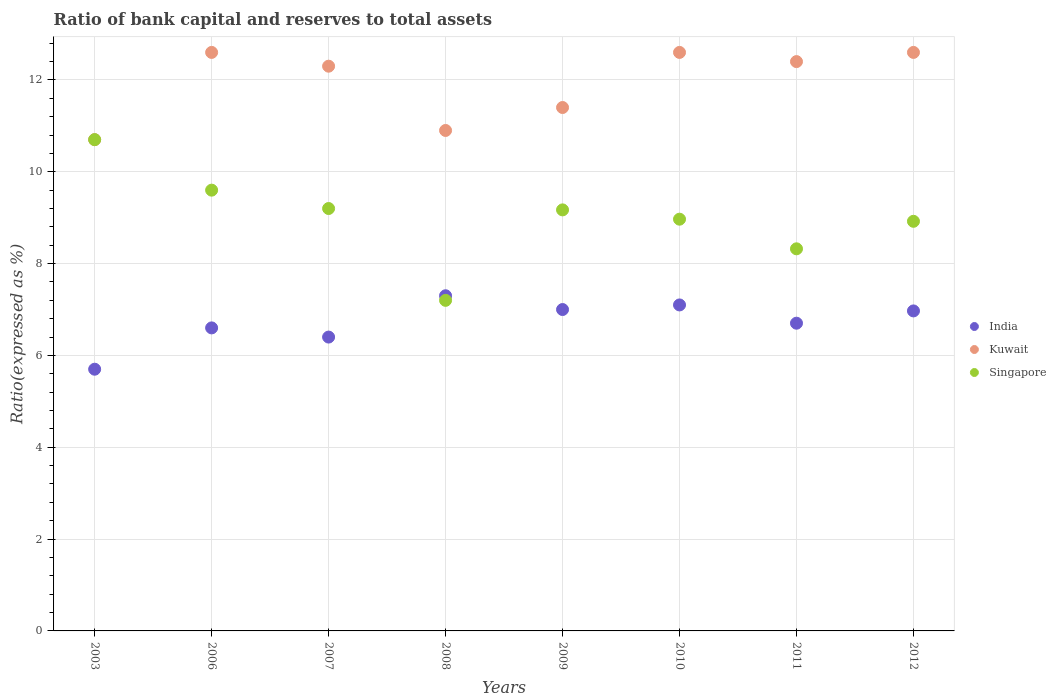Is the number of dotlines equal to the number of legend labels?
Offer a very short reply. Yes. Across all years, what is the minimum ratio of bank capital and reserves to total assets in Kuwait?
Provide a succinct answer. 10.7. What is the total ratio of bank capital and reserves to total assets in India in the graph?
Offer a very short reply. 53.77. What is the difference between the ratio of bank capital and reserves to total assets in India in 2009 and that in 2012?
Keep it short and to the point. 0.03. What is the difference between the ratio of bank capital and reserves to total assets in Singapore in 2003 and the ratio of bank capital and reserves to total assets in India in 2012?
Ensure brevity in your answer.  3.73. What is the average ratio of bank capital and reserves to total assets in Kuwait per year?
Give a very brief answer. 11.94. In the year 2009, what is the difference between the ratio of bank capital and reserves to total assets in India and ratio of bank capital and reserves to total assets in Singapore?
Your answer should be compact. -2.17. In how many years, is the ratio of bank capital and reserves to total assets in India greater than 8.8 %?
Offer a terse response. 0. What is the ratio of the ratio of bank capital and reserves to total assets in India in 2009 to that in 2010?
Give a very brief answer. 0.99. Is the difference between the ratio of bank capital and reserves to total assets in India in 2011 and 2012 greater than the difference between the ratio of bank capital and reserves to total assets in Singapore in 2011 and 2012?
Offer a terse response. Yes. What is the difference between the highest and the lowest ratio of bank capital and reserves to total assets in Singapore?
Provide a succinct answer. 3.5. Is the sum of the ratio of bank capital and reserves to total assets in India in 2006 and 2010 greater than the maximum ratio of bank capital and reserves to total assets in Kuwait across all years?
Keep it short and to the point. Yes. Is it the case that in every year, the sum of the ratio of bank capital and reserves to total assets in India and ratio of bank capital and reserves to total assets in Kuwait  is greater than the ratio of bank capital and reserves to total assets in Singapore?
Your response must be concise. Yes. Does the ratio of bank capital and reserves to total assets in Singapore monotonically increase over the years?
Your answer should be compact. No. Is the ratio of bank capital and reserves to total assets in Singapore strictly greater than the ratio of bank capital and reserves to total assets in India over the years?
Your response must be concise. No. How many years are there in the graph?
Give a very brief answer. 8. What is the difference between two consecutive major ticks on the Y-axis?
Your answer should be very brief. 2. Does the graph contain any zero values?
Give a very brief answer. No. Does the graph contain grids?
Your answer should be compact. Yes. What is the title of the graph?
Offer a terse response. Ratio of bank capital and reserves to total assets. What is the label or title of the Y-axis?
Provide a short and direct response. Ratio(expressed as %). What is the Ratio(expressed as %) of India in 2003?
Your answer should be very brief. 5.7. What is the Ratio(expressed as %) in Kuwait in 2003?
Provide a succinct answer. 10.7. What is the Ratio(expressed as %) in Singapore in 2003?
Provide a succinct answer. 10.7. What is the Ratio(expressed as %) of India in 2006?
Offer a terse response. 6.6. What is the Ratio(expressed as %) of Singapore in 2006?
Offer a terse response. 9.6. What is the Ratio(expressed as %) of India in 2007?
Your response must be concise. 6.4. What is the Ratio(expressed as %) in Kuwait in 2007?
Make the answer very short. 12.3. What is the Ratio(expressed as %) in Singapore in 2007?
Keep it short and to the point. 9.2. What is the Ratio(expressed as %) in Singapore in 2008?
Provide a short and direct response. 7.2. What is the Ratio(expressed as %) of Kuwait in 2009?
Ensure brevity in your answer.  11.4. What is the Ratio(expressed as %) in Singapore in 2009?
Provide a succinct answer. 9.17. What is the Ratio(expressed as %) in India in 2010?
Your answer should be compact. 7.1. What is the Ratio(expressed as %) in Kuwait in 2010?
Offer a terse response. 12.6. What is the Ratio(expressed as %) in Singapore in 2010?
Provide a succinct answer. 8.97. What is the Ratio(expressed as %) in India in 2011?
Provide a succinct answer. 6.7. What is the Ratio(expressed as %) in Kuwait in 2011?
Make the answer very short. 12.4. What is the Ratio(expressed as %) of Singapore in 2011?
Give a very brief answer. 8.32. What is the Ratio(expressed as %) in India in 2012?
Provide a short and direct response. 6.97. What is the Ratio(expressed as %) in Kuwait in 2012?
Provide a succinct answer. 12.6. What is the Ratio(expressed as %) in Singapore in 2012?
Ensure brevity in your answer.  8.92. Across all years, what is the maximum Ratio(expressed as %) of Singapore?
Your response must be concise. 10.7. Across all years, what is the minimum Ratio(expressed as %) in Singapore?
Keep it short and to the point. 7.2. What is the total Ratio(expressed as %) in India in the graph?
Provide a short and direct response. 53.77. What is the total Ratio(expressed as %) of Kuwait in the graph?
Make the answer very short. 95.5. What is the total Ratio(expressed as %) of Singapore in the graph?
Your answer should be compact. 72.08. What is the difference between the Ratio(expressed as %) of Kuwait in 2003 and that in 2006?
Your answer should be compact. -1.9. What is the difference between the Ratio(expressed as %) of India in 2003 and that in 2008?
Your answer should be very brief. -1.6. What is the difference between the Ratio(expressed as %) of Kuwait in 2003 and that in 2008?
Offer a very short reply. -0.2. What is the difference between the Ratio(expressed as %) in India in 2003 and that in 2009?
Keep it short and to the point. -1.3. What is the difference between the Ratio(expressed as %) in Kuwait in 2003 and that in 2009?
Provide a succinct answer. -0.7. What is the difference between the Ratio(expressed as %) in Singapore in 2003 and that in 2009?
Your answer should be compact. 1.53. What is the difference between the Ratio(expressed as %) of Kuwait in 2003 and that in 2010?
Provide a succinct answer. -1.9. What is the difference between the Ratio(expressed as %) of Singapore in 2003 and that in 2010?
Provide a succinct answer. 1.73. What is the difference between the Ratio(expressed as %) of India in 2003 and that in 2011?
Your response must be concise. -1. What is the difference between the Ratio(expressed as %) in Singapore in 2003 and that in 2011?
Your response must be concise. 2.38. What is the difference between the Ratio(expressed as %) of India in 2003 and that in 2012?
Offer a very short reply. -1.27. What is the difference between the Ratio(expressed as %) of Singapore in 2003 and that in 2012?
Your answer should be very brief. 1.78. What is the difference between the Ratio(expressed as %) of India in 2006 and that in 2007?
Your answer should be very brief. 0.2. What is the difference between the Ratio(expressed as %) of Singapore in 2006 and that in 2007?
Make the answer very short. 0.4. What is the difference between the Ratio(expressed as %) of India in 2006 and that in 2008?
Your response must be concise. -0.7. What is the difference between the Ratio(expressed as %) of Kuwait in 2006 and that in 2008?
Offer a terse response. 1.7. What is the difference between the Ratio(expressed as %) of Kuwait in 2006 and that in 2009?
Your answer should be compact. 1.2. What is the difference between the Ratio(expressed as %) of Singapore in 2006 and that in 2009?
Provide a short and direct response. 0.43. What is the difference between the Ratio(expressed as %) of India in 2006 and that in 2010?
Provide a short and direct response. -0.5. What is the difference between the Ratio(expressed as %) in Kuwait in 2006 and that in 2010?
Offer a very short reply. 0. What is the difference between the Ratio(expressed as %) of Singapore in 2006 and that in 2010?
Keep it short and to the point. 0.63. What is the difference between the Ratio(expressed as %) in India in 2006 and that in 2011?
Ensure brevity in your answer.  -0.1. What is the difference between the Ratio(expressed as %) of Kuwait in 2006 and that in 2011?
Your response must be concise. 0.2. What is the difference between the Ratio(expressed as %) in Singapore in 2006 and that in 2011?
Your answer should be very brief. 1.28. What is the difference between the Ratio(expressed as %) of India in 2006 and that in 2012?
Make the answer very short. -0.37. What is the difference between the Ratio(expressed as %) of Kuwait in 2006 and that in 2012?
Provide a short and direct response. 0. What is the difference between the Ratio(expressed as %) in Singapore in 2006 and that in 2012?
Ensure brevity in your answer.  0.68. What is the difference between the Ratio(expressed as %) of Kuwait in 2007 and that in 2008?
Offer a terse response. 1.4. What is the difference between the Ratio(expressed as %) in Singapore in 2007 and that in 2008?
Keep it short and to the point. 2. What is the difference between the Ratio(expressed as %) of Singapore in 2007 and that in 2009?
Give a very brief answer. 0.03. What is the difference between the Ratio(expressed as %) in Kuwait in 2007 and that in 2010?
Give a very brief answer. -0.3. What is the difference between the Ratio(expressed as %) in Singapore in 2007 and that in 2010?
Give a very brief answer. 0.23. What is the difference between the Ratio(expressed as %) of India in 2007 and that in 2011?
Provide a succinct answer. -0.3. What is the difference between the Ratio(expressed as %) of Kuwait in 2007 and that in 2011?
Provide a succinct answer. -0.1. What is the difference between the Ratio(expressed as %) in Singapore in 2007 and that in 2011?
Your answer should be very brief. 0.88. What is the difference between the Ratio(expressed as %) of India in 2007 and that in 2012?
Keep it short and to the point. -0.57. What is the difference between the Ratio(expressed as %) of Singapore in 2007 and that in 2012?
Provide a short and direct response. 0.28. What is the difference between the Ratio(expressed as %) in Singapore in 2008 and that in 2009?
Offer a very short reply. -1.97. What is the difference between the Ratio(expressed as %) of India in 2008 and that in 2010?
Provide a succinct answer. 0.2. What is the difference between the Ratio(expressed as %) in Kuwait in 2008 and that in 2010?
Your response must be concise. -1.7. What is the difference between the Ratio(expressed as %) of Singapore in 2008 and that in 2010?
Your answer should be very brief. -1.77. What is the difference between the Ratio(expressed as %) of India in 2008 and that in 2011?
Offer a very short reply. 0.6. What is the difference between the Ratio(expressed as %) of Kuwait in 2008 and that in 2011?
Keep it short and to the point. -1.5. What is the difference between the Ratio(expressed as %) in Singapore in 2008 and that in 2011?
Give a very brief answer. -1.12. What is the difference between the Ratio(expressed as %) of India in 2008 and that in 2012?
Provide a succinct answer. 0.33. What is the difference between the Ratio(expressed as %) of Singapore in 2008 and that in 2012?
Offer a very short reply. -1.72. What is the difference between the Ratio(expressed as %) of India in 2009 and that in 2010?
Provide a succinct answer. -0.1. What is the difference between the Ratio(expressed as %) of Kuwait in 2009 and that in 2010?
Provide a short and direct response. -1.2. What is the difference between the Ratio(expressed as %) of Singapore in 2009 and that in 2010?
Offer a terse response. 0.2. What is the difference between the Ratio(expressed as %) in India in 2009 and that in 2011?
Provide a succinct answer. 0.3. What is the difference between the Ratio(expressed as %) in Kuwait in 2009 and that in 2011?
Your response must be concise. -1. What is the difference between the Ratio(expressed as %) in Singapore in 2009 and that in 2011?
Your response must be concise. 0.85. What is the difference between the Ratio(expressed as %) in India in 2009 and that in 2012?
Your answer should be compact. 0.03. What is the difference between the Ratio(expressed as %) in Kuwait in 2009 and that in 2012?
Provide a short and direct response. -1.2. What is the difference between the Ratio(expressed as %) of Singapore in 2009 and that in 2012?
Offer a terse response. 0.25. What is the difference between the Ratio(expressed as %) in India in 2010 and that in 2011?
Offer a terse response. 0.4. What is the difference between the Ratio(expressed as %) of Singapore in 2010 and that in 2011?
Give a very brief answer. 0.65. What is the difference between the Ratio(expressed as %) of India in 2010 and that in 2012?
Ensure brevity in your answer.  0.13. What is the difference between the Ratio(expressed as %) of Singapore in 2010 and that in 2012?
Your answer should be very brief. 0.05. What is the difference between the Ratio(expressed as %) in India in 2011 and that in 2012?
Give a very brief answer. -0.27. What is the difference between the Ratio(expressed as %) in Kuwait in 2011 and that in 2012?
Your answer should be very brief. -0.2. What is the difference between the Ratio(expressed as %) of Singapore in 2011 and that in 2012?
Your response must be concise. -0.6. What is the difference between the Ratio(expressed as %) of India in 2003 and the Ratio(expressed as %) of Singapore in 2006?
Your answer should be very brief. -3.9. What is the difference between the Ratio(expressed as %) in Kuwait in 2003 and the Ratio(expressed as %) in Singapore in 2007?
Give a very brief answer. 1.5. What is the difference between the Ratio(expressed as %) in India in 2003 and the Ratio(expressed as %) in Kuwait in 2008?
Offer a terse response. -5.2. What is the difference between the Ratio(expressed as %) in India in 2003 and the Ratio(expressed as %) in Singapore in 2008?
Offer a terse response. -1.5. What is the difference between the Ratio(expressed as %) in India in 2003 and the Ratio(expressed as %) in Singapore in 2009?
Make the answer very short. -3.47. What is the difference between the Ratio(expressed as %) of Kuwait in 2003 and the Ratio(expressed as %) of Singapore in 2009?
Your answer should be very brief. 1.53. What is the difference between the Ratio(expressed as %) in India in 2003 and the Ratio(expressed as %) in Kuwait in 2010?
Offer a very short reply. -6.9. What is the difference between the Ratio(expressed as %) of India in 2003 and the Ratio(expressed as %) of Singapore in 2010?
Provide a succinct answer. -3.27. What is the difference between the Ratio(expressed as %) of Kuwait in 2003 and the Ratio(expressed as %) of Singapore in 2010?
Ensure brevity in your answer.  1.73. What is the difference between the Ratio(expressed as %) in India in 2003 and the Ratio(expressed as %) in Kuwait in 2011?
Offer a terse response. -6.7. What is the difference between the Ratio(expressed as %) of India in 2003 and the Ratio(expressed as %) of Singapore in 2011?
Your answer should be very brief. -2.62. What is the difference between the Ratio(expressed as %) of Kuwait in 2003 and the Ratio(expressed as %) of Singapore in 2011?
Your response must be concise. 2.38. What is the difference between the Ratio(expressed as %) of India in 2003 and the Ratio(expressed as %) of Singapore in 2012?
Offer a very short reply. -3.22. What is the difference between the Ratio(expressed as %) of Kuwait in 2003 and the Ratio(expressed as %) of Singapore in 2012?
Ensure brevity in your answer.  1.78. What is the difference between the Ratio(expressed as %) in India in 2006 and the Ratio(expressed as %) in Singapore in 2007?
Your answer should be very brief. -2.6. What is the difference between the Ratio(expressed as %) of Kuwait in 2006 and the Ratio(expressed as %) of Singapore in 2007?
Make the answer very short. 3.4. What is the difference between the Ratio(expressed as %) in India in 2006 and the Ratio(expressed as %) in Singapore in 2009?
Provide a short and direct response. -2.57. What is the difference between the Ratio(expressed as %) in Kuwait in 2006 and the Ratio(expressed as %) in Singapore in 2009?
Ensure brevity in your answer.  3.43. What is the difference between the Ratio(expressed as %) in India in 2006 and the Ratio(expressed as %) in Kuwait in 2010?
Keep it short and to the point. -6. What is the difference between the Ratio(expressed as %) in India in 2006 and the Ratio(expressed as %) in Singapore in 2010?
Your response must be concise. -2.37. What is the difference between the Ratio(expressed as %) of Kuwait in 2006 and the Ratio(expressed as %) of Singapore in 2010?
Ensure brevity in your answer.  3.63. What is the difference between the Ratio(expressed as %) of India in 2006 and the Ratio(expressed as %) of Singapore in 2011?
Provide a short and direct response. -1.72. What is the difference between the Ratio(expressed as %) of Kuwait in 2006 and the Ratio(expressed as %) of Singapore in 2011?
Offer a very short reply. 4.28. What is the difference between the Ratio(expressed as %) of India in 2006 and the Ratio(expressed as %) of Kuwait in 2012?
Ensure brevity in your answer.  -6. What is the difference between the Ratio(expressed as %) in India in 2006 and the Ratio(expressed as %) in Singapore in 2012?
Keep it short and to the point. -2.32. What is the difference between the Ratio(expressed as %) in Kuwait in 2006 and the Ratio(expressed as %) in Singapore in 2012?
Make the answer very short. 3.68. What is the difference between the Ratio(expressed as %) of India in 2007 and the Ratio(expressed as %) of Kuwait in 2008?
Your answer should be compact. -4.5. What is the difference between the Ratio(expressed as %) in India in 2007 and the Ratio(expressed as %) in Singapore in 2008?
Provide a succinct answer. -0.8. What is the difference between the Ratio(expressed as %) in India in 2007 and the Ratio(expressed as %) in Singapore in 2009?
Give a very brief answer. -2.77. What is the difference between the Ratio(expressed as %) of Kuwait in 2007 and the Ratio(expressed as %) of Singapore in 2009?
Offer a very short reply. 3.13. What is the difference between the Ratio(expressed as %) of India in 2007 and the Ratio(expressed as %) of Kuwait in 2010?
Provide a short and direct response. -6.2. What is the difference between the Ratio(expressed as %) in India in 2007 and the Ratio(expressed as %) in Singapore in 2010?
Offer a very short reply. -2.57. What is the difference between the Ratio(expressed as %) of Kuwait in 2007 and the Ratio(expressed as %) of Singapore in 2010?
Your answer should be very brief. 3.33. What is the difference between the Ratio(expressed as %) in India in 2007 and the Ratio(expressed as %) in Singapore in 2011?
Your answer should be compact. -1.92. What is the difference between the Ratio(expressed as %) of Kuwait in 2007 and the Ratio(expressed as %) of Singapore in 2011?
Provide a short and direct response. 3.98. What is the difference between the Ratio(expressed as %) in India in 2007 and the Ratio(expressed as %) in Singapore in 2012?
Make the answer very short. -2.52. What is the difference between the Ratio(expressed as %) of Kuwait in 2007 and the Ratio(expressed as %) of Singapore in 2012?
Your answer should be compact. 3.38. What is the difference between the Ratio(expressed as %) in India in 2008 and the Ratio(expressed as %) in Kuwait in 2009?
Ensure brevity in your answer.  -4.1. What is the difference between the Ratio(expressed as %) of India in 2008 and the Ratio(expressed as %) of Singapore in 2009?
Provide a succinct answer. -1.87. What is the difference between the Ratio(expressed as %) in Kuwait in 2008 and the Ratio(expressed as %) in Singapore in 2009?
Your response must be concise. 1.73. What is the difference between the Ratio(expressed as %) of India in 2008 and the Ratio(expressed as %) of Kuwait in 2010?
Provide a short and direct response. -5.3. What is the difference between the Ratio(expressed as %) of India in 2008 and the Ratio(expressed as %) of Singapore in 2010?
Give a very brief answer. -1.67. What is the difference between the Ratio(expressed as %) in Kuwait in 2008 and the Ratio(expressed as %) in Singapore in 2010?
Keep it short and to the point. 1.93. What is the difference between the Ratio(expressed as %) in India in 2008 and the Ratio(expressed as %) in Kuwait in 2011?
Keep it short and to the point. -5.1. What is the difference between the Ratio(expressed as %) in India in 2008 and the Ratio(expressed as %) in Singapore in 2011?
Offer a terse response. -1.02. What is the difference between the Ratio(expressed as %) of Kuwait in 2008 and the Ratio(expressed as %) of Singapore in 2011?
Offer a terse response. 2.58. What is the difference between the Ratio(expressed as %) in India in 2008 and the Ratio(expressed as %) in Singapore in 2012?
Your answer should be compact. -1.62. What is the difference between the Ratio(expressed as %) of Kuwait in 2008 and the Ratio(expressed as %) of Singapore in 2012?
Your answer should be compact. 1.98. What is the difference between the Ratio(expressed as %) of India in 2009 and the Ratio(expressed as %) of Kuwait in 2010?
Ensure brevity in your answer.  -5.6. What is the difference between the Ratio(expressed as %) in India in 2009 and the Ratio(expressed as %) in Singapore in 2010?
Your response must be concise. -1.97. What is the difference between the Ratio(expressed as %) in Kuwait in 2009 and the Ratio(expressed as %) in Singapore in 2010?
Keep it short and to the point. 2.43. What is the difference between the Ratio(expressed as %) in India in 2009 and the Ratio(expressed as %) in Kuwait in 2011?
Provide a short and direct response. -5.4. What is the difference between the Ratio(expressed as %) in India in 2009 and the Ratio(expressed as %) in Singapore in 2011?
Your answer should be very brief. -1.32. What is the difference between the Ratio(expressed as %) of Kuwait in 2009 and the Ratio(expressed as %) of Singapore in 2011?
Your response must be concise. 3.08. What is the difference between the Ratio(expressed as %) of India in 2009 and the Ratio(expressed as %) of Kuwait in 2012?
Provide a short and direct response. -5.6. What is the difference between the Ratio(expressed as %) of India in 2009 and the Ratio(expressed as %) of Singapore in 2012?
Your answer should be very brief. -1.92. What is the difference between the Ratio(expressed as %) of Kuwait in 2009 and the Ratio(expressed as %) of Singapore in 2012?
Provide a short and direct response. 2.48. What is the difference between the Ratio(expressed as %) of India in 2010 and the Ratio(expressed as %) of Kuwait in 2011?
Make the answer very short. -5.3. What is the difference between the Ratio(expressed as %) of India in 2010 and the Ratio(expressed as %) of Singapore in 2011?
Make the answer very short. -1.22. What is the difference between the Ratio(expressed as %) of Kuwait in 2010 and the Ratio(expressed as %) of Singapore in 2011?
Your answer should be compact. 4.28. What is the difference between the Ratio(expressed as %) of India in 2010 and the Ratio(expressed as %) of Kuwait in 2012?
Provide a short and direct response. -5.5. What is the difference between the Ratio(expressed as %) of India in 2010 and the Ratio(expressed as %) of Singapore in 2012?
Provide a succinct answer. -1.82. What is the difference between the Ratio(expressed as %) in Kuwait in 2010 and the Ratio(expressed as %) in Singapore in 2012?
Provide a short and direct response. 3.68. What is the difference between the Ratio(expressed as %) in India in 2011 and the Ratio(expressed as %) in Kuwait in 2012?
Provide a short and direct response. -5.9. What is the difference between the Ratio(expressed as %) in India in 2011 and the Ratio(expressed as %) in Singapore in 2012?
Offer a terse response. -2.22. What is the difference between the Ratio(expressed as %) in Kuwait in 2011 and the Ratio(expressed as %) in Singapore in 2012?
Keep it short and to the point. 3.48. What is the average Ratio(expressed as %) in India per year?
Your response must be concise. 6.72. What is the average Ratio(expressed as %) of Kuwait per year?
Provide a succinct answer. 11.94. What is the average Ratio(expressed as %) in Singapore per year?
Your response must be concise. 9.01. In the year 2003, what is the difference between the Ratio(expressed as %) in India and Ratio(expressed as %) in Kuwait?
Your answer should be very brief. -5. In the year 2003, what is the difference between the Ratio(expressed as %) in Kuwait and Ratio(expressed as %) in Singapore?
Give a very brief answer. 0. In the year 2006, what is the difference between the Ratio(expressed as %) of India and Ratio(expressed as %) of Kuwait?
Offer a terse response. -6. In the year 2006, what is the difference between the Ratio(expressed as %) of India and Ratio(expressed as %) of Singapore?
Ensure brevity in your answer.  -3. In the year 2006, what is the difference between the Ratio(expressed as %) in Kuwait and Ratio(expressed as %) in Singapore?
Make the answer very short. 3. In the year 2007, what is the difference between the Ratio(expressed as %) in India and Ratio(expressed as %) in Singapore?
Provide a short and direct response. -2.8. In the year 2007, what is the difference between the Ratio(expressed as %) in Kuwait and Ratio(expressed as %) in Singapore?
Ensure brevity in your answer.  3.1. In the year 2009, what is the difference between the Ratio(expressed as %) of India and Ratio(expressed as %) of Singapore?
Offer a very short reply. -2.17. In the year 2009, what is the difference between the Ratio(expressed as %) of Kuwait and Ratio(expressed as %) of Singapore?
Offer a very short reply. 2.23. In the year 2010, what is the difference between the Ratio(expressed as %) of India and Ratio(expressed as %) of Singapore?
Your answer should be compact. -1.87. In the year 2010, what is the difference between the Ratio(expressed as %) of Kuwait and Ratio(expressed as %) of Singapore?
Provide a short and direct response. 3.63. In the year 2011, what is the difference between the Ratio(expressed as %) in India and Ratio(expressed as %) in Kuwait?
Make the answer very short. -5.7. In the year 2011, what is the difference between the Ratio(expressed as %) of India and Ratio(expressed as %) of Singapore?
Ensure brevity in your answer.  -1.62. In the year 2011, what is the difference between the Ratio(expressed as %) in Kuwait and Ratio(expressed as %) in Singapore?
Give a very brief answer. 4.08. In the year 2012, what is the difference between the Ratio(expressed as %) in India and Ratio(expressed as %) in Kuwait?
Your response must be concise. -5.63. In the year 2012, what is the difference between the Ratio(expressed as %) in India and Ratio(expressed as %) in Singapore?
Your response must be concise. -1.95. In the year 2012, what is the difference between the Ratio(expressed as %) of Kuwait and Ratio(expressed as %) of Singapore?
Make the answer very short. 3.68. What is the ratio of the Ratio(expressed as %) in India in 2003 to that in 2006?
Offer a terse response. 0.86. What is the ratio of the Ratio(expressed as %) of Kuwait in 2003 to that in 2006?
Your answer should be very brief. 0.85. What is the ratio of the Ratio(expressed as %) of Singapore in 2003 to that in 2006?
Give a very brief answer. 1.11. What is the ratio of the Ratio(expressed as %) of India in 2003 to that in 2007?
Your answer should be very brief. 0.89. What is the ratio of the Ratio(expressed as %) in Kuwait in 2003 to that in 2007?
Keep it short and to the point. 0.87. What is the ratio of the Ratio(expressed as %) of Singapore in 2003 to that in 2007?
Your answer should be very brief. 1.16. What is the ratio of the Ratio(expressed as %) in India in 2003 to that in 2008?
Your answer should be compact. 0.78. What is the ratio of the Ratio(expressed as %) in Kuwait in 2003 to that in 2008?
Give a very brief answer. 0.98. What is the ratio of the Ratio(expressed as %) of Singapore in 2003 to that in 2008?
Provide a succinct answer. 1.49. What is the ratio of the Ratio(expressed as %) in India in 2003 to that in 2009?
Offer a terse response. 0.81. What is the ratio of the Ratio(expressed as %) in Kuwait in 2003 to that in 2009?
Ensure brevity in your answer.  0.94. What is the ratio of the Ratio(expressed as %) of Singapore in 2003 to that in 2009?
Ensure brevity in your answer.  1.17. What is the ratio of the Ratio(expressed as %) in India in 2003 to that in 2010?
Provide a succinct answer. 0.8. What is the ratio of the Ratio(expressed as %) of Kuwait in 2003 to that in 2010?
Give a very brief answer. 0.85. What is the ratio of the Ratio(expressed as %) in Singapore in 2003 to that in 2010?
Provide a short and direct response. 1.19. What is the ratio of the Ratio(expressed as %) in India in 2003 to that in 2011?
Give a very brief answer. 0.85. What is the ratio of the Ratio(expressed as %) of Kuwait in 2003 to that in 2011?
Your response must be concise. 0.86. What is the ratio of the Ratio(expressed as %) in Singapore in 2003 to that in 2011?
Offer a terse response. 1.29. What is the ratio of the Ratio(expressed as %) of India in 2003 to that in 2012?
Provide a succinct answer. 0.82. What is the ratio of the Ratio(expressed as %) of Kuwait in 2003 to that in 2012?
Ensure brevity in your answer.  0.85. What is the ratio of the Ratio(expressed as %) in Singapore in 2003 to that in 2012?
Ensure brevity in your answer.  1.2. What is the ratio of the Ratio(expressed as %) in India in 2006 to that in 2007?
Offer a very short reply. 1.03. What is the ratio of the Ratio(expressed as %) of Kuwait in 2006 to that in 2007?
Make the answer very short. 1.02. What is the ratio of the Ratio(expressed as %) in Singapore in 2006 to that in 2007?
Your response must be concise. 1.04. What is the ratio of the Ratio(expressed as %) of India in 2006 to that in 2008?
Provide a succinct answer. 0.9. What is the ratio of the Ratio(expressed as %) in Kuwait in 2006 to that in 2008?
Ensure brevity in your answer.  1.16. What is the ratio of the Ratio(expressed as %) in Singapore in 2006 to that in 2008?
Keep it short and to the point. 1.33. What is the ratio of the Ratio(expressed as %) in India in 2006 to that in 2009?
Ensure brevity in your answer.  0.94. What is the ratio of the Ratio(expressed as %) in Kuwait in 2006 to that in 2009?
Your answer should be very brief. 1.11. What is the ratio of the Ratio(expressed as %) in Singapore in 2006 to that in 2009?
Make the answer very short. 1.05. What is the ratio of the Ratio(expressed as %) of India in 2006 to that in 2010?
Your answer should be very brief. 0.93. What is the ratio of the Ratio(expressed as %) in Kuwait in 2006 to that in 2010?
Your response must be concise. 1. What is the ratio of the Ratio(expressed as %) of Singapore in 2006 to that in 2010?
Give a very brief answer. 1.07. What is the ratio of the Ratio(expressed as %) in India in 2006 to that in 2011?
Make the answer very short. 0.98. What is the ratio of the Ratio(expressed as %) of Kuwait in 2006 to that in 2011?
Keep it short and to the point. 1.02. What is the ratio of the Ratio(expressed as %) of Singapore in 2006 to that in 2011?
Your answer should be compact. 1.15. What is the ratio of the Ratio(expressed as %) of India in 2006 to that in 2012?
Your answer should be very brief. 0.95. What is the ratio of the Ratio(expressed as %) of Singapore in 2006 to that in 2012?
Ensure brevity in your answer.  1.08. What is the ratio of the Ratio(expressed as %) of India in 2007 to that in 2008?
Make the answer very short. 0.88. What is the ratio of the Ratio(expressed as %) in Kuwait in 2007 to that in 2008?
Provide a short and direct response. 1.13. What is the ratio of the Ratio(expressed as %) in Singapore in 2007 to that in 2008?
Make the answer very short. 1.28. What is the ratio of the Ratio(expressed as %) of India in 2007 to that in 2009?
Ensure brevity in your answer.  0.91. What is the ratio of the Ratio(expressed as %) of Kuwait in 2007 to that in 2009?
Offer a terse response. 1.08. What is the ratio of the Ratio(expressed as %) of Singapore in 2007 to that in 2009?
Make the answer very short. 1. What is the ratio of the Ratio(expressed as %) in India in 2007 to that in 2010?
Offer a very short reply. 0.9. What is the ratio of the Ratio(expressed as %) of Kuwait in 2007 to that in 2010?
Make the answer very short. 0.98. What is the ratio of the Ratio(expressed as %) in Singapore in 2007 to that in 2010?
Offer a very short reply. 1.03. What is the ratio of the Ratio(expressed as %) of India in 2007 to that in 2011?
Offer a terse response. 0.95. What is the ratio of the Ratio(expressed as %) in Kuwait in 2007 to that in 2011?
Your response must be concise. 0.99. What is the ratio of the Ratio(expressed as %) in Singapore in 2007 to that in 2011?
Your answer should be very brief. 1.11. What is the ratio of the Ratio(expressed as %) of India in 2007 to that in 2012?
Provide a succinct answer. 0.92. What is the ratio of the Ratio(expressed as %) in Kuwait in 2007 to that in 2012?
Your response must be concise. 0.98. What is the ratio of the Ratio(expressed as %) of Singapore in 2007 to that in 2012?
Give a very brief answer. 1.03. What is the ratio of the Ratio(expressed as %) in India in 2008 to that in 2009?
Offer a terse response. 1.04. What is the ratio of the Ratio(expressed as %) in Kuwait in 2008 to that in 2009?
Give a very brief answer. 0.96. What is the ratio of the Ratio(expressed as %) in Singapore in 2008 to that in 2009?
Ensure brevity in your answer.  0.79. What is the ratio of the Ratio(expressed as %) in India in 2008 to that in 2010?
Ensure brevity in your answer.  1.03. What is the ratio of the Ratio(expressed as %) in Kuwait in 2008 to that in 2010?
Make the answer very short. 0.87. What is the ratio of the Ratio(expressed as %) in Singapore in 2008 to that in 2010?
Provide a succinct answer. 0.8. What is the ratio of the Ratio(expressed as %) in India in 2008 to that in 2011?
Provide a short and direct response. 1.09. What is the ratio of the Ratio(expressed as %) in Kuwait in 2008 to that in 2011?
Offer a very short reply. 0.88. What is the ratio of the Ratio(expressed as %) of Singapore in 2008 to that in 2011?
Your response must be concise. 0.87. What is the ratio of the Ratio(expressed as %) of India in 2008 to that in 2012?
Give a very brief answer. 1.05. What is the ratio of the Ratio(expressed as %) in Kuwait in 2008 to that in 2012?
Give a very brief answer. 0.87. What is the ratio of the Ratio(expressed as %) in Singapore in 2008 to that in 2012?
Your answer should be very brief. 0.81. What is the ratio of the Ratio(expressed as %) in India in 2009 to that in 2010?
Give a very brief answer. 0.99. What is the ratio of the Ratio(expressed as %) in Kuwait in 2009 to that in 2010?
Provide a succinct answer. 0.9. What is the ratio of the Ratio(expressed as %) in Singapore in 2009 to that in 2010?
Your answer should be very brief. 1.02. What is the ratio of the Ratio(expressed as %) of India in 2009 to that in 2011?
Keep it short and to the point. 1.04. What is the ratio of the Ratio(expressed as %) of Kuwait in 2009 to that in 2011?
Keep it short and to the point. 0.92. What is the ratio of the Ratio(expressed as %) of Singapore in 2009 to that in 2011?
Provide a succinct answer. 1.1. What is the ratio of the Ratio(expressed as %) of Kuwait in 2009 to that in 2012?
Make the answer very short. 0.9. What is the ratio of the Ratio(expressed as %) in Singapore in 2009 to that in 2012?
Offer a terse response. 1.03. What is the ratio of the Ratio(expressed as %) of India in 2010 to that in 2011?
Offer a very short reply. 1.06. What is the ratio of the Ratio(expressed as %) in Kuwait in 2010 to that in 2011?
Offer a terse response. 1.02. What is the ratio of the Ratio(expressed as %) of Singapore in 2010 to that in 2011?
Your answer should be very brief. 1.08. What is the ratio of the Ratio(expressed as %) of India in 2010 to that in 2012?
Offer a terse response. 1.02. What is the ratio of the Ratio(expressed as %) in Kuwait in 2010 to that in 2012?
Provide a succinct answer. 1. What is the ratio of the Ratio(expressed as %) of India in 2011 to that in 2012?
Keep it short and to the point. 0.96. What is the ratio of the Ratio(expressed as %) of Kuwait in 2011 to that in 2012?
Offer a terse response. 0.98. What is the ratio of the Ratio(expressed as %) in Singapore in 2011 to that in 2012?
Make the answer very short. 0.93. What is the difference between the highest and the second highest Ratio(expressed as %) in Kuwait?
Make the answer very short. 0. What is the difference between the highest and the lowest Ratio(expressed as %) in India?
Ensure brevity in your answer.  1.6. 